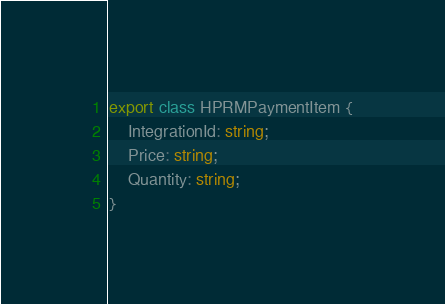<code> <loc_0><loc_0><loc_500><loc_500><_TypeScript_>export class HPRMPaymentItem {
    IntegrationId: string;
    Price: string;
    Quantity: string;
}
</code> 